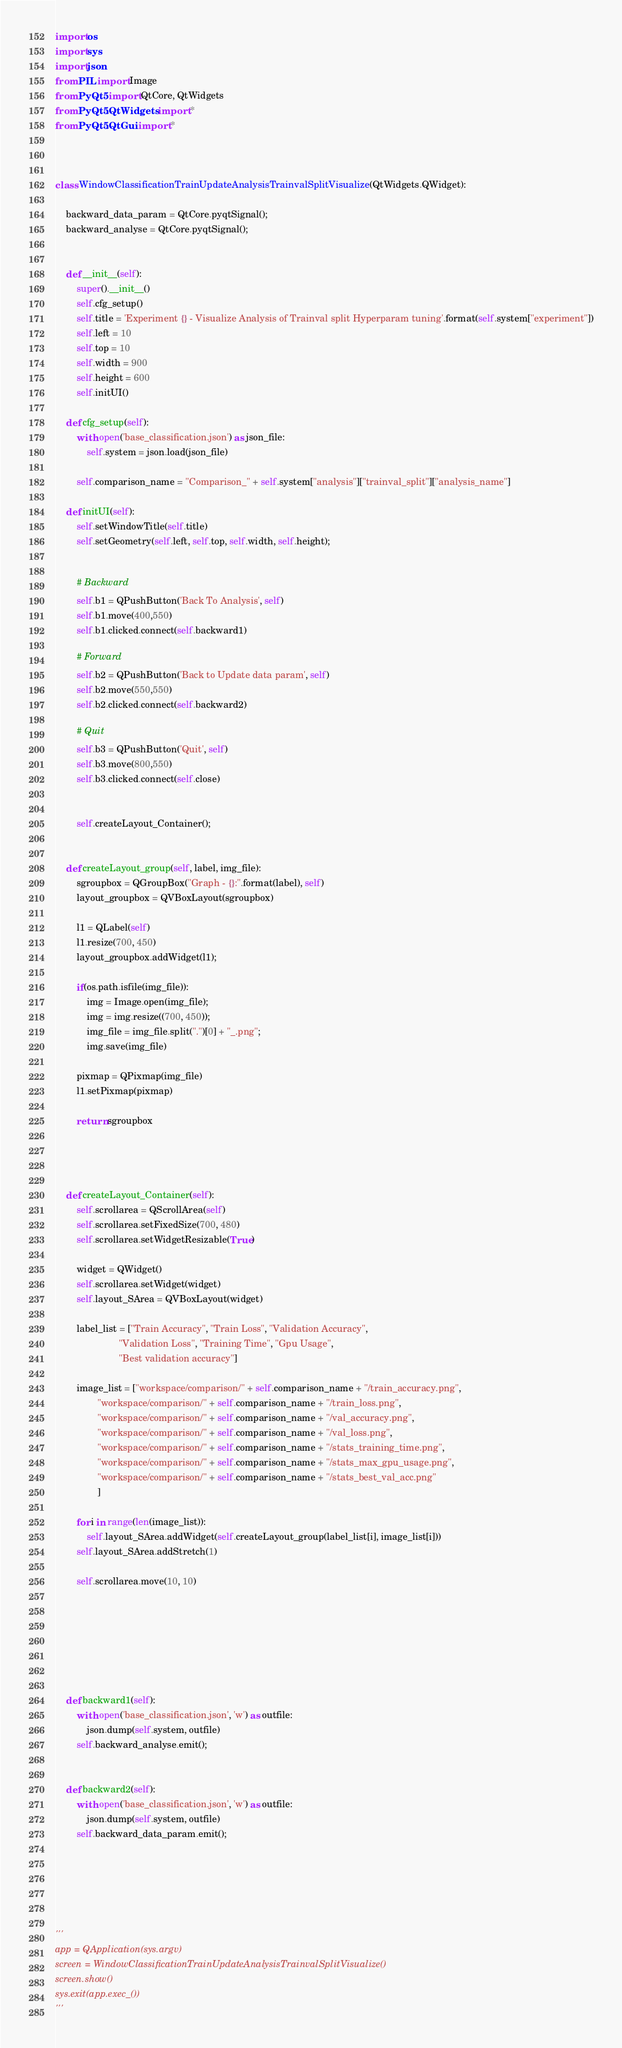Convert code to text. <code><loc_0><loc_0><loc_500><loc_500><_Python_>import os
import sys
import json
from PIL import Image
from PyQt5 import QtCore, QtWidgets
from PyQt5.QtWidgets import *
from PyQt5.QtGui import *



class WindowClassificationTrainUpdateAnalysisTrainvalSplitVisualize(QtWidgets.QWidget):

    backward_data_param = QtCore.pyqtSignal();
    backward_analyse = QtCore.pyqtSignal();


    def __init__(self):
        super().__init__()
        self.cfg_setup()
        self.title = 'Experiment {} - Visualize Analysis of Trainval split Hyperparam tuning'.format(self.system["experiment"])
        self.left = 10
        self.top = 10
        self.width = 900
        self.height = 600
        self.initUI()

    def cfg_setup(self):
        with open('base_classification.json') as json_file:
            self.system = json.load(json_file)

        self.comparison_name = "Comparison_" + self.system["analysis"]["trainval_split"]["analysis_name"]

    def initUI(self):
        self.setWindowTitle(self.title)
        self.setGeometry(self.left, self.top, self.width, self.height);


        # Backward
        self.b1 = QPushButton('Back To Analysis', self)
        self.b1.move(400,550)
        self.b1.clicked.connect(self.backward1)

        # Forward
        self.b2 = QPushButton('Back to Update data param', self)
        self.b2.move(550,550)
        self.b2.clicked.connect(self.backward2)

        # Quit
        self.b3 = QPushButton('Quit', self)
        self.b3.move(800,550)
        self.b3.clicked.connect(self.close)


        self.createLayout_Container();


    def createLayout_group(self, label, img_file):
        sgroupbox = QGroupBox("Graph - {}:".format(label), self)
        layout_groupbox = QVBoxLayout(sgroupbox)

        l1 = QLabel(self)
        l1.resize(700, 450)
        layout_groupbox.addWidget(l1);
        
        if(os.path.isfile(img_file)):
            img = Image.open(img_file);
            img = img.resize((700, 450));
            img_file = img_file.split(".")[0] + "_.png"; 
            img.save(img_file)

        pixmap = QPixmap(img_file)
        l1.setPixmap(pixmap)

        return sgroupbox




    def createLayout_Container(self):
        self.scrollarea = QScrollArea(self)
        self.scrollarea.setFixedSize(700, 480)
        self.scrollarea.setWidgetResizable(True)

        widget = QWidget()
        self.scrollarea.setWidget(widget)
        self.layout_SArea = QVBoxLayout(widget)

        label_list = ["Train Accuracy", "Train Loss", "Validation Accuracy", 
                        "Validation Loss", "Training Time", "Gpu Usage", 
                        "Best validation accuracy"]

        image_list = ["workspace/comparison/" + self.comparison_name + "/train_accuracy.png",
                "workspace/comparison/" + self.comparison_name + "/train_loss.png",
                "workspace/comparison/" + self.comparison_name + "/val_accuracy.png",
                "workspace/comparison/" + self.comparison_name + "/val_loss.png",
                "workspace/comparison/" + self.comparison_name + "/stats_training_time.png",
                "workspace/comparison/" + self.comparison_name + "/stats_max_gpu_usage.png",
                "workspace/comparison/" + self.comparison_name + "/stats_best_val_acc.png"
                ]

        for i in range(len(image_list)):
            self.layout_SArea.addWidget(self.createLayout_group(label_list[i], image_list[i]))
        self.layout_SArea.addStretch(1)

        self.scrollarea.move(10, 10)


        
        



    def backward1(self):
        with open('base_classification.json', 'w') as outfile:
            json.dump(self.system, outfile)
        self.backward_analyse.emit();


    def backward2(self):
        with open('base_classification.json', 'w') as outfile:
            json.dump(self.system, outfile)
        self.backward_data_param.emit();


    



'''
app = QApplication(sys.argv)
screen = WindowClassificationTrainUpdateAnalysisTrainvalSplitVisualize()
screen.show()
sys.exit(app.exec_())
'''</code> 